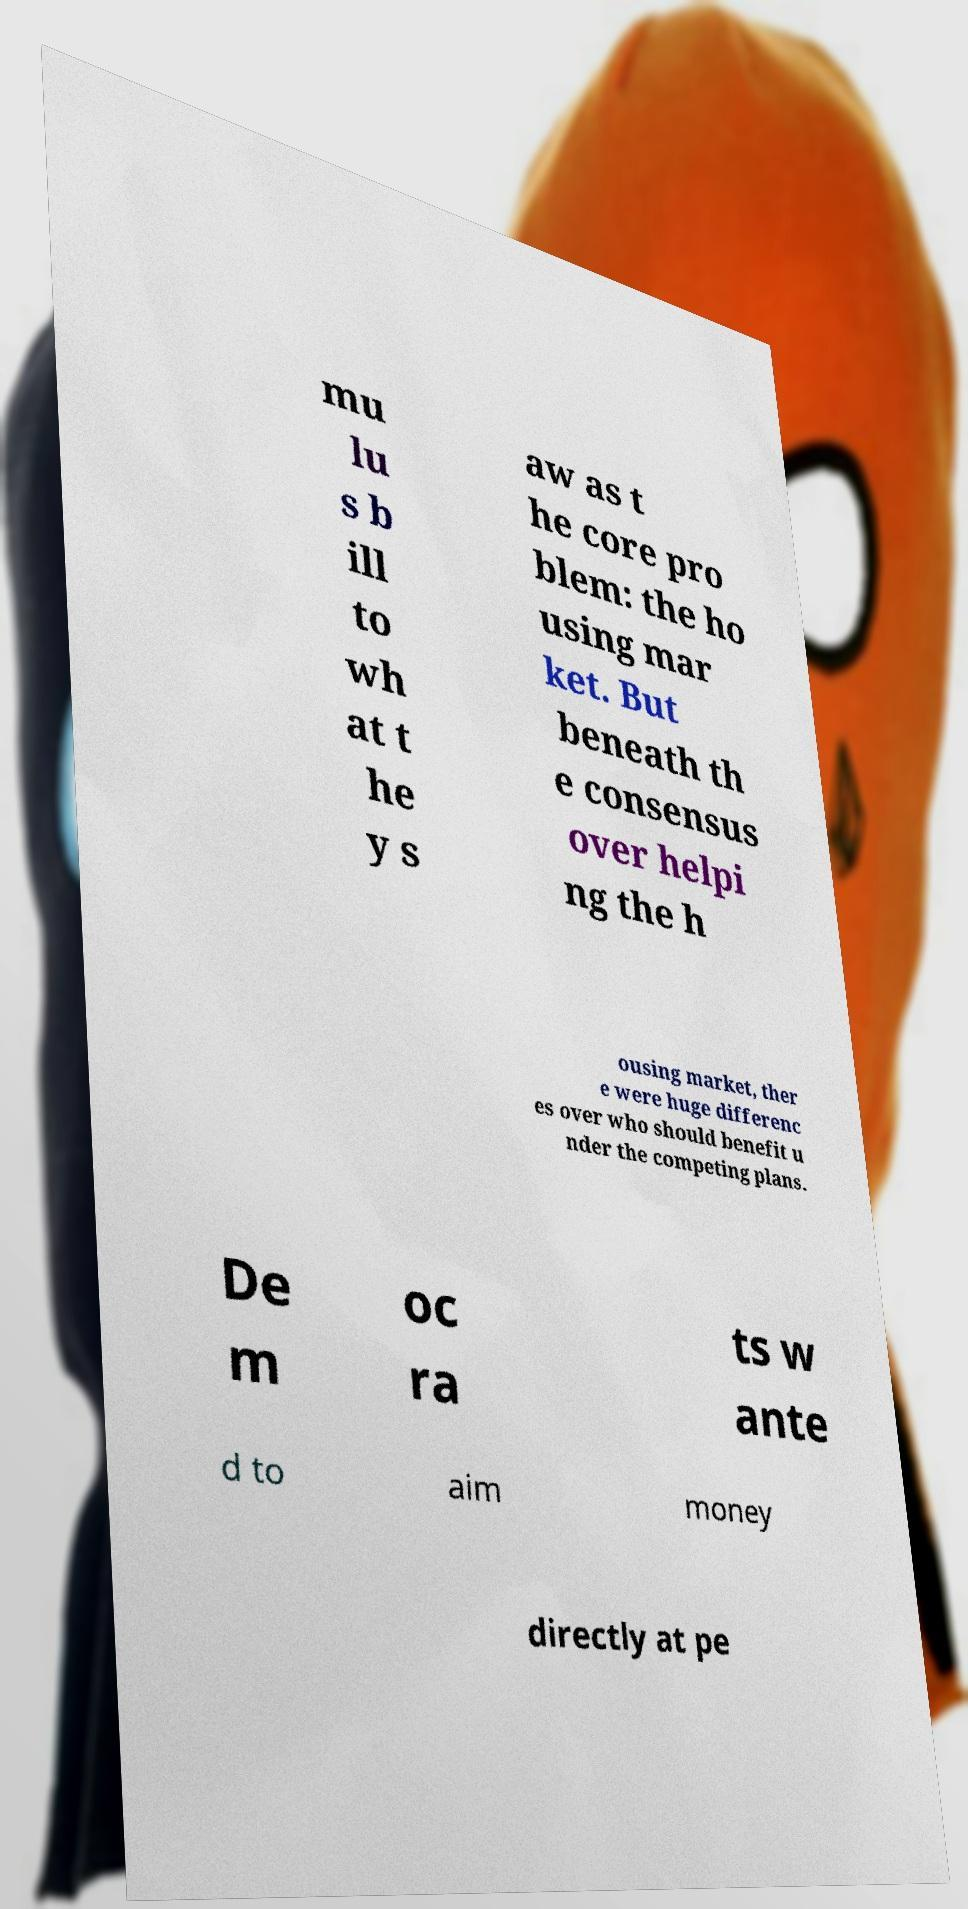Could you extract and type out the text from this image? mu lu s b ill to wh at t he y s aw as t he core pro blem: the ho using mar ket. But beneath th e consensus over helpi ng the h ousing market, ther e were huge differenc es over who should benefit u nder the competing plans. De m oc ra ts w ante d to aim money directly at pe 